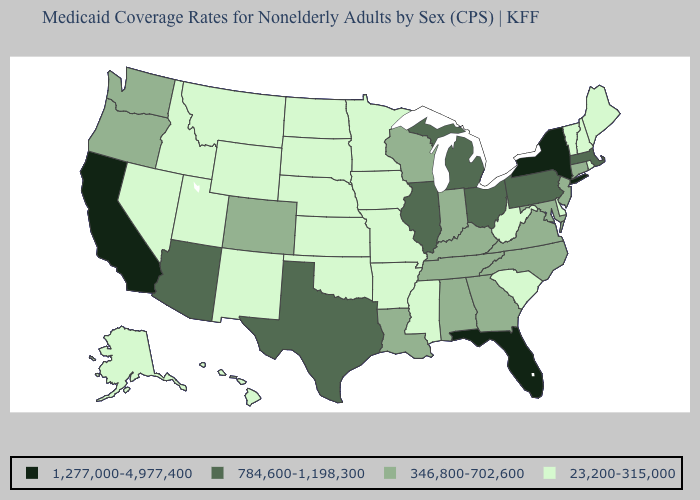Among the states that border Illinois , which have the lowest value?
Write a very short answer. Iowa, Missouri. Does Oregon have the lowest value in the USA?
Keep it brief. No. Which states have the lowest value in the USA?
Be succinct. Alaska, Arkansas, Delaware, Hawaii, Idaho, Iowa, Kansas, Maine, Minnesota, Mississippi, Missouri, Montana, Nebraska, Nevada, New Hampshire, New Mexico, North Dakota, Oklahoma, Rhode Island, South Carolina, South Dakota, Utah, Vermont, West Virginia, Wyoming. What is the value of Florida?
Short answer required. 1,277,000-4,977,400. Does North Carolina have the lowest value in the USA?
Concise answer only. No. What is the lowest value in the MidWest?
Keep it brief. 23,200-315,000. Name the states that have a value in the range 1,277,000-4,977,400?
Concise answer only. California, Florida, New York. Name the states that have a value in the range 23,200-315,000?
Keep it brief. Alaska, Arkansas, Delaware, Hawaii, Idaho, Iowa, Kansas, Maine, Minnesota, Mississippi, Missouri, Montana, Nebraska, Nevada, New Hampshire, New Mexico, North Dakota, Oklahoma, Rhode Island, South Carolina, South Dakota, Utah, Vermont, West Virginia, Wyoming. Among the states that border Minnesota , does Iowa have the highest value?
Keep it brief. No. What is the lowest value in states that border Nevada?
Keep it brief. 23,200-315,000. What is the value of Texas?
Give a very brief answer. 784,600-1,198,300. Does the map have missing data?
Give a very brief answer. No. What is the highest value in the USA?
Write a very short answer. 1,277,000-4,977,400. Which states have the lowest value in the Northeast?
Keep it brief. Maine, New Hampshire, Rhode Island, Vermont. Name the states that have a value in the range 1,277,000-4,977,400?
Short answer required. California, Florida, New York. 